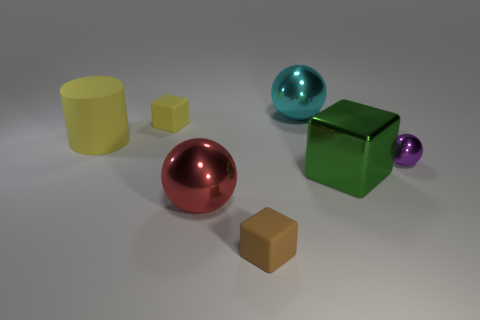Add 2 big things. How many objects exist? 9 Subtract all cylinders. How many objects are left? 6 Add 4 red shiny balls. How many red shiny balls exist? 5 Subtract 1 brown blocks. How many objects are left? 6 Subtract all tiny red matte objects. Subtract all cylinders. How many objects are left? 6 Add 1 brown matte things. How many brown matte things are left? 2 